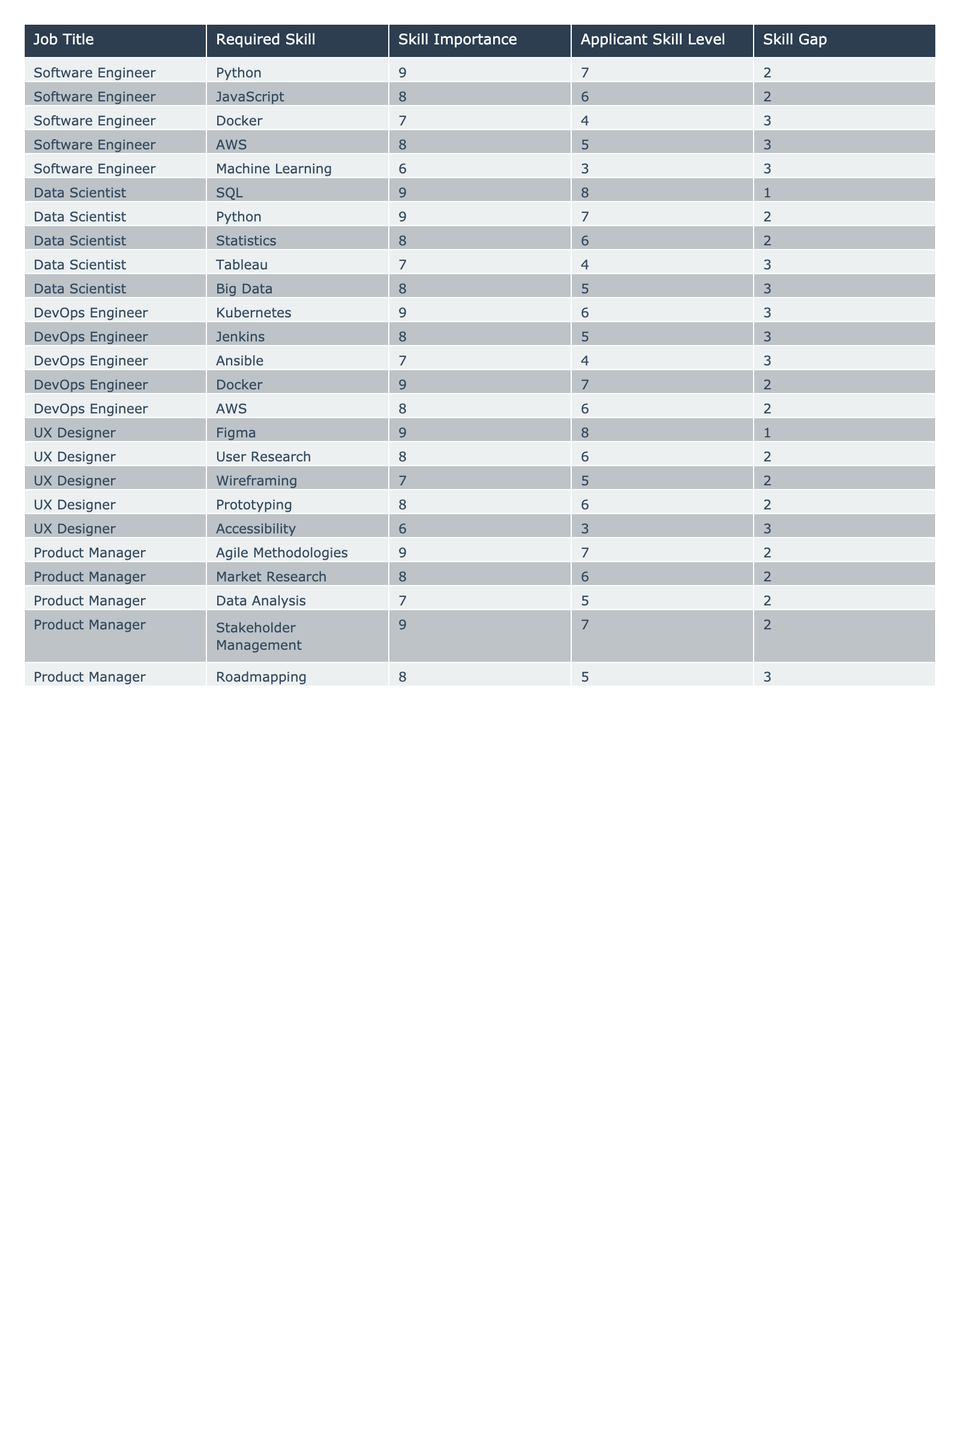What is the highest skill gap for Software Engineers? The table shows the skill gaps for Software Engineers, and the highest gap is for the skill "Docker" with a skill gap of 3.
Answer: 3 Which position has the least skill gap in Data Science? In the Data Scientist role, the skill with the least gap is "SQL," where the skill gap is only 1.
Answer: 1 Which job title requires proficiency in Kubernetes? Upon reviewing the table, it is clear that the job title "DevOps Engineer" requires proficiency in Kubernetes.
Answer: DevOps Engineer How many skills have a skill gap of 2 in total? By counting all the "Skill Gap" values that equal 2 across the job titles, we find there are 5 instances: Software Engineer(2), Data Scientist(2), DevOps Engineer(2), UX Designer(2), Product Manager(2).
Answer: 5 Is there a skill gap for Data Analysis in the Product Manager role? Looking at the row for "Data Analysis" under Product Manager, there is a skill gap of 2, indicating a gap in that skill.
Answer: Yes What is the average skill gap for the role of UX Designer? The skill gaps for UX Designer are 1, 2, 2, 2, and 3. Summing these gives: 1 + 2 + 2 + 2 + 3 = 10. There are 5 skills, so the average is 10/5 = 2.
Answer: 2 Which skill has the highest importance rating across all positions? The highest importance rating in the table is 9, which appears multiple times including for "Python," "Kubernetes," and "Figma." Hence, no single skill holds the highest rating.
Answer: Python, Kubernetes, Figma How many non-development positions are listed? The non-development position in the table is "UX Designer" and "Product Manager," totaling 2 positions.
Answer: 2 What is the total sum of skill gaps for all positions? By adding all skill gaps: 2 (SW Eng) + 2 + 3 + 3 + 3 (DATA Sci) + 3 + 2 + 2 (DevOps) + 1 + 2 + 2 + 2 (UX) + 2 + 2 + 3 (PM) = 35.
Answer: 35 Which required skill for Software Engineers has the highest importance? Reviewing the required skills for Software Engineers, "Python," has the highest importance rating of 9.
Answer: Python 